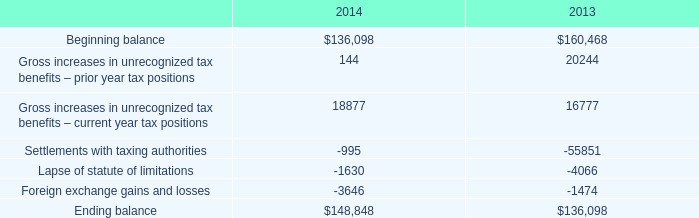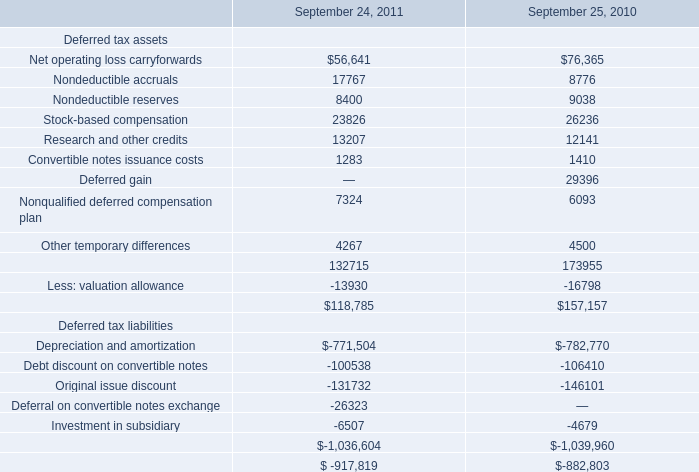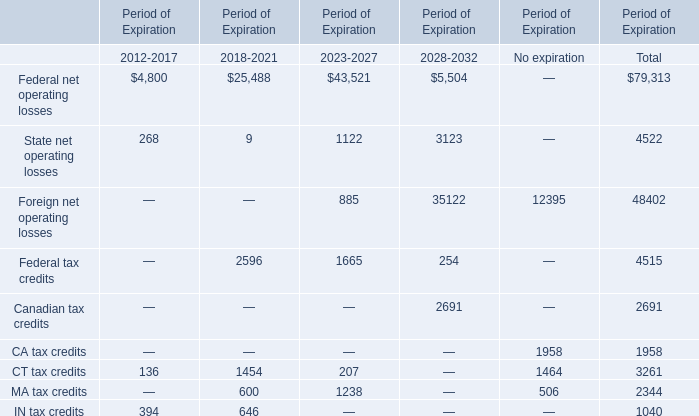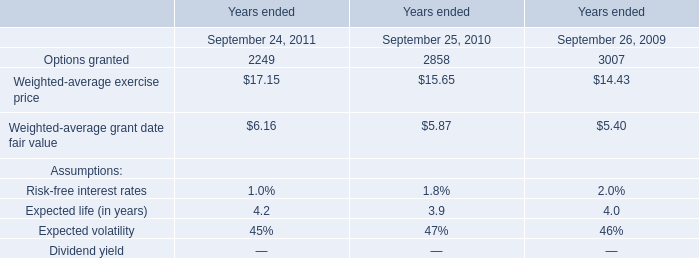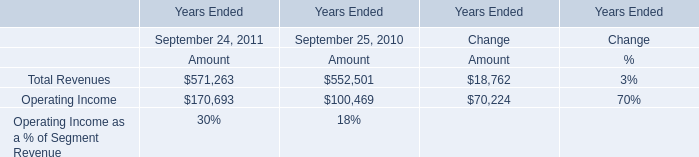What's the sum of Investment in subsidiary Deferred tax liabilities of September 24, 2011, and Settlements with taxing authorities of 2013 ? 
Computations: (6507.0 + 55851.0)
Answer: 62358.0. 